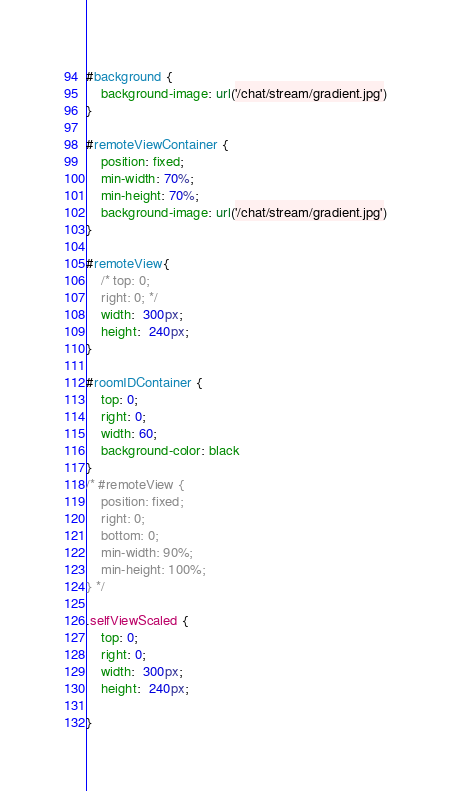Convert code to text. <code><loc_0><loc_0><loc_500><loc_500><_CSS_>#background {
    background-image: url('/chat/stream/gradient.jpg')
}

#remoteViewContainer {
    position: fixed;
    min-width: 70%; 
    min-height: 70%;
    background-image: url('/chat/stream/gradient.jpg')
}

#remoteView{
    /* top: 0;
    right: 0; */
    width:  300px;
    height:  240px;
}

#roomIDContainer {
    top: 0;
    right: 0;
    width: 60;
    background-color: black
}
/* #remoteView {
    position: fixed; 
    right: 0; 
    bottom: 0; 
    min-width: 90%; 
    min-height: 100%;
} */

.selfViewScaled {
    top: 0;
    right: 0;
    width:  300px;
    height:  240px;
   
}

</code> 